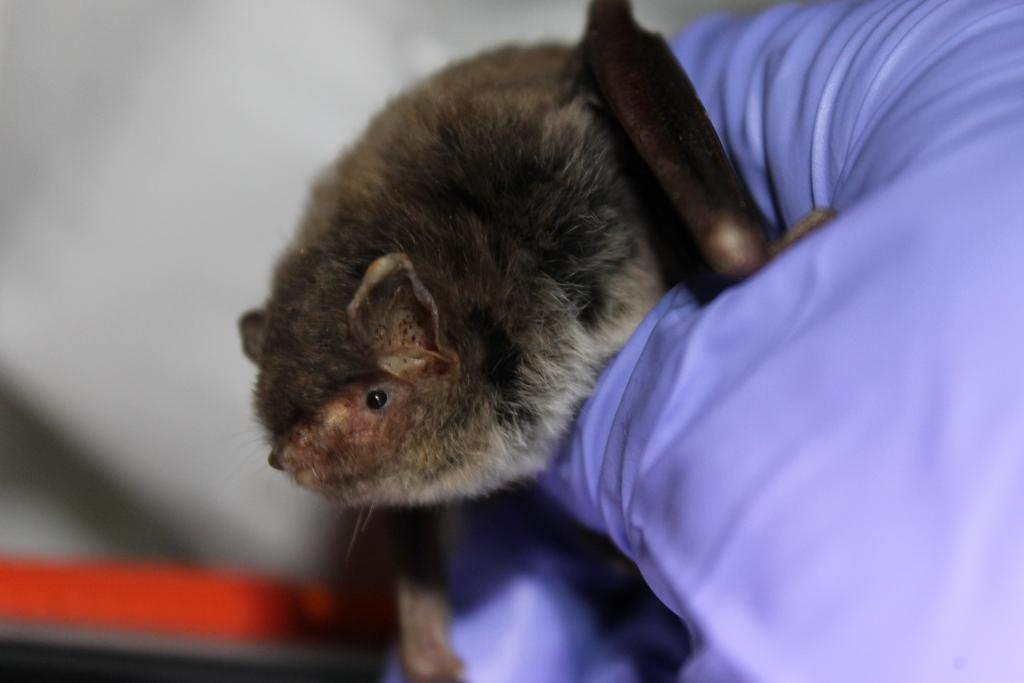What type of animal is in the image? There is an evening bat in the image. Where is the evening bat located? The evening bat is on a pillow. What type of chicken is present at the event in the image? There is no chicken or event present in the image; it features an evening bat on a pillow. 